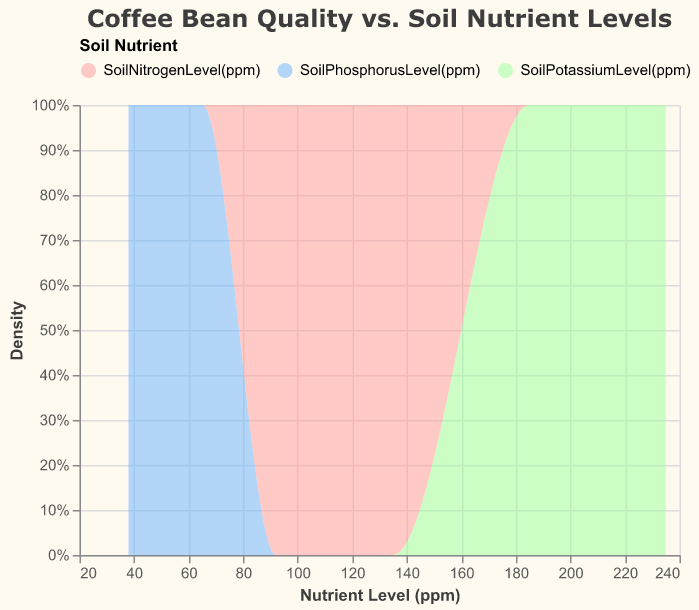What is the title of the figure? The title of the figure is displayed at the top and usually provides a summary of what the chart is about. In this case, it's a descriptive text at the top.
Answer: "Coffee Bean Quality vs. Soil Nutrient Levels" What are the x-axis and y-axis labels? The x-axis label is at the bottom and describes the nutrient levels in ppm, while the y-axis label is on the left and describes the density of data points.
Answer: Nutrient Level (ppm), Density How many different soil nutrients are represented in the plot? The color legend at the top indicates three different nutrient types represented by three different colors.
Answer: 3 What color represents Soil Nitrogen Level in the plot? The legend at the top of the plot indicates the color associated with each nutrient. Soil Nitrogen Level is represented by the first color in the legend.
Answer: Red How does the density of Soil Potassium Level compare to Soil Phosphorus Level at higher ppm values? The height of the colored areas corresponding to the Soil Potassium Level and Soil Phosphorus Level can be compared in the high ppm range on the x-axis. Soil Potassium Level shows higher density as its area is taller.
Answer: Higher Which farm section has the highest coffee bean quality rating? To determine the highest coffee bean quality rating, compare the ratings provided in the data for each farm section and identify the maximum value.
Answer: EastField Do Soil Nitrogen Levels have a higher density at lower or higher ppm values? By observing the area under the red section of the density plot, one can see if its density is higher at the lower or higher ppm range. The plot indicates a higher density at higher ppm values.
Answer: Higher Which nutrient has the least density representation at around 50 ppm? By inspecting the density areas around 50 ppm on the x-axis, we can identify which nutrient has the smallest area, indicating the least density.
Answer: Soil Phosphorus Level What's the average Coffee Bean Quality (Rating) in the NorthField? Calculate the average of the given Coffee Bean Quality ratings for the NorthField data points. Sum the ratings (8.7 + 8.5 + 8.9) and divide by the number of data points (3) to get the average.
Answer: 8.7 